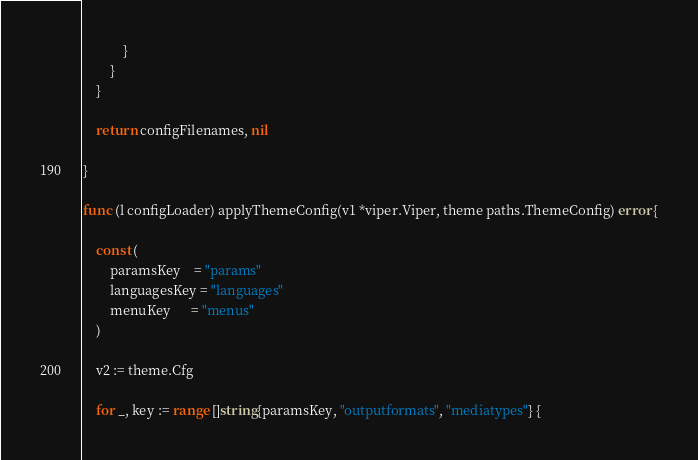Convert code to text. <code><loc_0><loc_0><loc_500><loc_500><_Go_>			}
		}
	}

	return configFilenames, nil

}

func (l configLoader) applyThemeConfig(v1 *viper.Viper, theme paths.ThemeConfig) error {

	const (
		paramsKey    = "params"
		languagesKey = "languages"
		menuKey      = "menus"
	)

	v2 := theme.Cfg

	for _, key := range []string{paramsKey, "outputformats", "mediatypes"} {</code> 